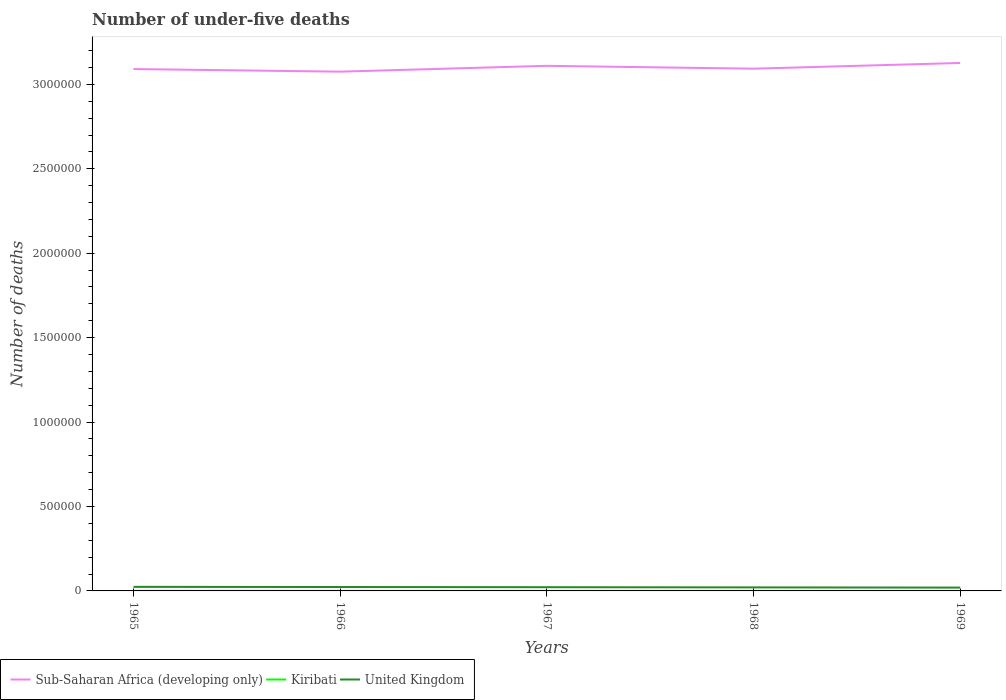Across all years, what is the maximum number of under-five deaths in Kiribati?
Provide a short and direct response. 256. In which year was the number of under-five deaths in United Kingdom maximum?
Offer a terse response. 1969. What is the total number of under-five deaths in Sub-Saharan Africa (developing only) in the graph?
Give a very brief answer. 1.54e+04. What is the difference between the highest and the second highest number of under-five deaths in Sub-Saharan Africa (developing only)?
Your response must be concise. 5.14e+04. How many years are there in the graph?
Your answer should be very brief. 5. Are the values on the major ticks of Y-axis written in scientific E-notation?
Your response must be concise. No. How many legend labels are there?
Make the answer very short. 3. How are the legend labels stacked?
Your answer should be very brief. Horizontal. What is the title of the graph?
Offer a terse response. Number of under-five deaths. Does "Argentina" appear as one of the legend labels in the graph?
Your response must be concise. No. What is the label or title of the X-axis?
Provide a short and direct response. Years. What is the label or title of the Y-axis?
Provide a succinct answer. Number of deaths. What is the Number of deaths of Sub-Saharan Africa (developing only) in 1965?
Make the answer very short. 3.09e+06. What is the Number of deaths of Kiribati in 1965?
Keep it short and to the point. 321. What is the Number of deaths in United Kingdom in 1965?
Your answer should be very brief. 2.41e+04. What is the Number of deaths of Sub-Saharan Africa (developing only) in 1966?
Your answer should be very brief. 3.08e+06. What is the Number of deaths of Kiribati in 1966?
Give a very brief answer. 306. What is the Number of deaths in United Kingdom in 1966?
Give a very brief answer. 2.32e+04. What is the Number of deaths in Sub-Saharan Africa (developing only) in 1967?
Ensure brevity in your answer.  3.11e+06. What is the Number of deaths of Kiribati in 1967?
Your answer should be compact. 289. What is the Number of deaths of United Kingdom in 1967?
Ensure brevity in your answer.  2.20e+04. What is the Number of deaths of Sub-Saharan Africa (developing only) in 1968?
Your answer should be very brief. 3.09e+06. What is the Number of deaths of Kiribati in 1968?
Your answer should be very brief. 272. What is the Number of deaths in United Kingdom in 1968?
Your answer should be very brief. 2.09e+04. What is the Number of deaths of Sub-Saharan Africa (developing only) in 1969?
Keep it short and to the point. 3.13e+06. What is the Number of deaths in Kiribati in 1969?
Provide a short and direct response. 256. What is the Number of deaths of United Kingdom in 1969?
Provide a short and direct response. 1.97e+04. Across all years, what is the maximum Number of deaths of Sub-Saharan Africa (developing only)?
Offer a terse response. 3.13e+06. Across all years, what is the maximum Number of deaths in Kiribati?
Ensure brevity in your answer.  321. Across all years, what is the maximum Number of deaths of United Kingdom?
Give a very brief answer. 2.41e+04. Across all years, what is the minimum Number of deaths of Sub-Saharan Africa (developing only)?
Provide a succinct answer. 3.08e+06. Across all years, what is the minimum Number of deaths in Kiribati?
Ensure brevity in your answer.  256. Across all years, what is the minimum Number of deaths in United Kingdom?
Your response must be concise. 1.97e+04. What is the total Number of deaths of Sub-Saharan Africa (developing only) in the graph?
Make the answer very short. 1.55e+07. What is the total Number of deaths of Kiribati in the graph?
Provide a short and direct response. 1444. What is the total Number of deaths in United Kingdom in the graph?
Give a very brief answer. 1.10e+05. What is the difference between the Number of deaths in Sub-Saharan Africa (developing only) in 1965 and that in 1966?
Make the answer very short. 1.54e+04. What is the difference between the Number of deaths in United Kingdom in 1965 and that in 1966?
Provide a short and direct response. 955. What is the difference between the Number of deaths of Sub-Saharan Africa (developing only) in 1965 and that in 1967?
Offer a very short reply. -1.91e+04. What is the difference between the Number of deaths of Kiribati in 1965 and that in 1967?
Keep it short and to the point. 32. What is the difference between the Number of deaths in United Kingdom in 1965 and that in 1967?
Ensure brevity in your answer.  2127. What is the difference between the Number of deaths of Sub-Saharan Africa (developing only) in 1965 and that in 1968?
Provide a short and direct response. -2131. What is the difference between the Number of deaths in United Kingdom in 1965 and that in 1968?
Provide a short and direct response. 3232. What is the difference between the Number of deaths in Sub-Saharan Africa (developing only) in 1965 and that in 1969?
Make the answer very short. -3.60e+04. What is the difference between the Number of deaths in Kiribati in 1965 and that in 1969?
Your answer should be very brief. 65. What is the difference between the Number of deaths of United Kingdom in 1965 and that in 1969?
Your answer should be compact. 4390. What is the difference between the Number of deaths of Sub-Saharan Africa (developing only) in 1966 and that in 1967?
Provide a short and direct response. -3.45e+04. What is the difference between the Number of deaths in United Kingdom in 1966 and that in 1967?
Your answer should be very brief. 1172. What is the difference between the Number of deaths in Sub-Saharan Africa (developing only) in 1966 and that in 1968?
Your answer should be very brief. -1.76e+04. What is the difference between the Number of deaths in Kiribati in 1966 and that in 1968?
Ensure brevity in your answer.  34. What is the difference between the Number of deaths of United Kingdom in 1966 and that in 1968?
Offer a very short reply. 2277. What is the difference between the Number of deaths of Sub-Saharan Africa (developing only) in 1966 and that in 1969?
Your answer should be compact. -5.14e+04. What is the difference between the Number of deaths in Kiribati in 1966 and that in 1969?
Offer a terse response. 50. What is the difference between the Number of deaths of United Kingdom in 1966 and that in 1969?
Your response must be concise. 3435. What is the difference between the Number of deaths in Sub-Saharan Africa (developing only) in 1967 and that in 1968?
Offer a terse response. 1.70e+04. What is the difference between the Number of deaths in United Kingdom in 1967 and that in 1968?
Keep it short and to the point. 1105. What is the difference between the Number of deaths of Sub-Saharan Africa (developing only) in 1967 and that in 1969?
Make the answer very short. -1.69e+04. What is the difference between the Number of deaths in United Kingdom in 1967 and that in 1969?
Provide a short and direct response. 2263. What is the difference between the Number of deaths in Sub-Saharan Africa (developing only) in 1968 and that in 1969?
Your response must be concise. -3.39e+04. What is the difference between the Number of deaths of Kiribati in 1968 and that in 1969?
Provide a succinct answer. 16. What is the difference between the Number of deaths in United Kingdom in 1968 and that in 1969?
Keep it short and to the point. 1158. What is the difference between the Number of deaths in Sub-Saharan Africa (developing only) in 1965 and the Number of deaths in Kiribati in 1966?
Your response must be concise. 3.09e+06. What is the difference between the Number of deaths of Sub-Saharan Africa (developing only) in 1965 and the Number of deaths of United Kingdom in 1966?
Keep it short and to the point. 3.07e+06. What is the difference between the Number of deaths in Kiribati in 1965 and the Number of deaths in United Kingdom in 1966?
Provide a succinct answer. -2.28e+04. What is the difference between the Number of deaths in Sub-Saharan Africa (developing only) in 1965 and the Number of deaths in Kiribati in 1967?
Provide a succinct answer. 3.09e+06. What is the difference between the Number of deaths in Sub-Saharan Africa (developing only) in 1965 and the Number of deaths in United Kingdom in 1967?
Provide a short and direct response. 3.07e+06. What is the difference between the Number of deaths in Kiribati in 1965 and the Number of deaths in United Kingdom in 1967?
Keep it short and to the point. -2.17e+04. What is the difference between the Number of deaths of Sub-Saharan Africa (developing only) in 1965 and the Number of deaths of Kiribati in 1968?
Your answer should be very brief. 3.09e+06. What is the difference between the Number of deaths in Sub-Saharan Africa (developing only) in 1965 and the Number of deaths in United Kingdom in 1968?
Provide a succinct answer. 3.07e+06. What is the difference between the Number of deaths in Kiribati in 1965 and the Number of deaths in United Kingdom in 1968?
Provide a succinct answer. -2.06e+04. What is the difference between the Number of deaths in Sub-Saharan Africa (developing only) in 1965 and the Number of deaths in Kiribati in 1969?
Keep it short and to the point. 3.09e+06. What is the difference between the Number of deaths of Sub-Saharan Africa (developing only) in 1965 and the Number of deaths of United Kingdom in 1969?
Offer a terse response. 3.07e+06. What is the difference between the Number of deaths in Kiribati in 1965 and the Number of deaths in United Kingdom in 1969?
Give a very brief answer. -1.94e+04. What is the difference between the Number of deaths in Sub-Saharan Africa (developing only) in 1966 and the Number of deaths in Kiribati in 1967?
Make the answer very short. 3.07e+06. What is the difference between the Number of deaths in Sub-Saharan Africa (developing only) in 1966 and the Number of deaths in United Kingdom in 1967?
Give a very brief answer. 3.05e+06. What is the difference between the Number of deaths in Kiribati in 1966 and the Number of deaths in United Kingdom in 1967?
Your answer should be compact. -2.17e+04. What is the difference between the Number of deaths of Sub-Saharan Africa (developing only) in 1966 and the Number of deaths of Kiribati in 1968?
Ensure brevity in your answer.  3.07e+06. What is the difference between the Number of deaths in Sub-Saharan Africa (developing only) in 1966 and the Number of deaths in United Kingdom in 1968?
Make the answer very short. 3.05e+06. What is the difference between the Number of deaths in Kiribati in 1966 and the Number of deaths in United Kingdom in 1968?
Keep it short and to the point. -2.06e+04. What is the difference between the Number of deaths of Sub-Saharan Africa (developing only) in 1966 and the Number of deaths of Kiribati in 1969?
Your answer should be compact. 3.07e+06. What is the difference between the Number of deaths of Sub-Saharan Africa (developing only) in 1966 and the Number of deaths of United Kingdom in 1969?
Offer a terse response. 3.06e+06. What is the difference between the Number of deaths of Kiribati in 1966 and the Number of deaths of United Kingdom in 1969?
Give a very brief answer. -1.94e+04. What is the difference between the Number of deaths in Sub-Saharan Africa (developing only) in 1967 and the Number of deaths in Kiribati in 1968?
Provide a short and direct response. 3.11e+06. What is the difference between the Number of deaths of Sub-Saharan Africa (developing only) in 1967 and the Number of deaths of United Kingdom in 1968?
Ensure brevity in your answer.  3.09e+06. What is the difference between the Number of deaths in Kiribati in 1967 and the Number of deaths in United Kingdom in 1968?
Your response must be concise. -2.06e+04. What is the difference between the Number of deaths of Sub-Saharan Africa (developing only) in 1967 and the Number of deaths of Kiribati in 1969?
Offer a very short reply. 3.11e+06. What is the difference between the Number of deaths of Sub-Saharan Africa (developing only) in 1967 and the Number of deaths of United Kingdom in 1969?
Offer a very short reply. 3.09e+06. What is the difference between the Number of deaths of Kiribati in 1967 and the Number of deaths of United Kingdom in 1969?
Keep it short and to the point. -1.94e+04. What is the difference between the Number of deaths of Sub-Saharan Africa (developing only) in 1968 and the Number of deaths of Kiribati in 1969?
Your answer should be compact. 3.09e+06. What is the difference between the Number of deaths in Sub-Saharan Africa (developing only) in 1968 and the Number of deaths in United Kingdom in 1969?
Provide a succinct answer. 3.07e+06. What is the difference between the Number of deaths in Kiribati in 1968 and the Number of deaths in United Kingdom in 1969?
Your answer should be very brief. -1.94e+04. What is the average Number of deaths in Sub-Saharan Africa (developing only) per year?
Offer a very short reply. 3.10e+06. What is the average Number of deaths of Kiribati per year?
Your answer should be compact. 288.8. What is the average Number of deaths of United Kingdom per year?
Your response must be concise. 2.20e+04. In the year 1965, what is the difference between the Number of deaths of Sub-Saharan Africa (developing only) and Number of deaths of Kiribati?
Offer a very short reply. 3.09e+06. In the year 1965, what is the difference between the Number of deaths in Sub-Saharan Africa (developing only) and Number of deaths in United Kingdom?
Your answer should be compact. 3.07e+06. In the year 1965, what is the difference between the Number of deaths in Kiribati and Number of deaths in United Kingdom?
Keep it short and to the point. -2.38e+04. In the year 1966, what is the difference between the Number of deaths of Sub-Saharan Africa (developing only) and Number of deaths of Kiribati?
Your answer should be very brief. 3.07e+06. In the year 1966, what is the difference between the Number of deaths of Sub-Saharan Africa (developing only) and Number of deaths of United Kingdom?
Keep it short and to the point. 3.05e+06. In the year 1966, what is the difference between the Number of deaths of Kiribati and Number of deaths of United Kingdom?
Your answer should be compact. -2.28e+04. In the year 1967, what is the difference between the Number of deaths in Sub-Saharan Africa (developing only) and Number of deaths in Kiribati?
Your response must be concise. 3.11e+06. In the year 1967, what is the difference between the Number of deaths of Sub-Saharan Africa (developing only) and Number of deaths of United Kingdom?
Your answer should be very brief. 3.09e+06. In the year 1967, what is the difference between the Number of deaths of Kiribati and Number of deaths of United Kingdom?
Give a very brief answer. -2.17e+04. In the year 1968, what is the difference between the Number of deaths in Sub-Saharan Africa (developing only) and Number of deaths in Kiribati?
Your response must be concise. 3.09e+06. In the year 1968, what is the difference between the Number of deaths of Sub-Saharan Africa (developing only) and Number of deaths of United Kingdom?
Make the answer very short. 3.07e+06. In the year 1968, what is the difference between the Number of deaths of Kiribati and Number of deaths of United Kingdom?
Ensure brevity in your answer.  -2.06e+04. In the year 1969, what is the difference between the Number of deaths of Sub-Saharan Africa (developing only) and Number of deaths of Kiribati?
Give a very brief answer. 3.13e+06. In the year 1969, what is the difference between the Number of deaths of Sub-Saharan Africa (developing only) and Number of deaths of United Kingdom?
Your answer should be very brief. 3.11e+06. In the year 1969, what is the difference between the Number of deaths of Kiribati and Number of deaths of United Kingdom?
Provide a succinct answer. -1.95e+04. What is the ratio of the Number of deaths in Kiribati in 1965 to that in 1966?
Your response must be concise. 1.05. What is the ratio of the Number of deaths of United Kingdom in 1965 to that in 1966?
Your response must be concise. 1.04. What is the ratio of the Number of deaths in Sub-Saharan Africa (developing only) in 1965 to that in 1967?
Offer a very short reply. 0.99. What is the ratio of the Number of deaths in Kiribati in 1965 to that in 1967?
Offer a very short reply. 1.11. What is the ratio of the Number of deaths in United Kingdom in 1965 to that in 1967?
Provide a short and direct response. 1.1. What is the ratio of the Number of deaths of Kiribati in 1965 to that in 1968?
Offer a very short reply. 1.18. What is the ratio of the Number of deaths of United Kingdom in 1965 to that in 1968?
Keep it short and to the point. 1.15. What is the ratio of the Number of deaths of Sub-Saharan Africa (developing only) in 1965 to that in 1969?
Offer a terse response. 0.99. What is the ratio of the Number of deaths of Kiribati in 1965 to that in 1969?
Provide a succinct answer. 1.25. What is the ratio of the Number of deaths of United Kingdom in 1965 to that in 1969?
Provide a short and direct response. 1.22. What is the ratio of the Number of deaths of Sub-Saharan Africa (developing only) in 1966 to that in 1967?
Provide a short and direct response. 0.99. What is the ratio of the Number of deaths in Kiribati in 1966 to that in 1967?
Make the answer very short. 1.06. What is the ratio of the Number of deaths in United Kingdom in 1966 to that in 1967?
Give a very brief answer. 1.05. What is the ratio of the Number of deaths in Sub-Saharan Africa (developing only) in 1966 to that in 1968?
Provide a succinct answer. 0.99. What is the ratio of the Number of deaths of Kiribati in 1966 to that in 1968?
Keep it short and to the point. 1.12. What is the ratio of the Number of deaths in United Kingdom in 1966 to that in 1968?
Keep it short and to the point. 1.11. What is the ratio of the Number of deaths of Sub-Saharan Africa (developing only) in 1966 to that in 1969?
Offer a terse response. 0.98. What is the ratio of the Number of deaths in Kiribati in 1966 to that in 1969?
Provide a succinct answer. 1.2. What is the ratio of the Number of deaths of United Kingdom in 1966 to that in 1969?
Offer a very short reply. 1.17. What is the ratio of the Number of deaths of Sub-Saharan Africa (developing only) in 1967 to that in 1968?
Keep it short and to the point. 1.01. What is the ratio of the Number of deaths of Kiribati in 1967 to that in 1968?
Make the answer very short. 1.06. What is the ratio of the Number of deaths in United Kingdom in 1967 to that in 1968?
Give a very brief answer. 1.05. What is the ratio of the Number of deaths of Kiribati in 1967 to that in 1969?
Make the answer very short. 1.13. What is the ratio of the Number of deaths in United Kingdom in 1967 to that in 1969?
Offer a terse response. 1.11. What is the ratio of the Number of deaths in Sub-Saharan Africa (developing only) in 1968 to that in 1969?
Make the answer very short. 0.99. What is the ratio of the Number of deaths in United Kingdom in 1968 to that in 1969?
Keep it short and to the point. 1.06. What is the difference between the highest and the second highest Number of deaths in Sub-Saharan Africa (developing only)?
Offer a very short reply. 1.69e+04. What is the difference between the highest and the second highest Number of deaths of Kiribati?
Provide a succinct answer. 15. What is the difference between the highest and the second highest Number of deaths in United Kingdom?
Provide a succinct answer. 955. What is the difference between the highest and the lowest Number of deaths in Sub-Saharan Africa (developing only)?
Ensure brevity in your answer.  5.14e+04. What is the difference between the highest and the lowest Number of deaths in United Kingdom?
Your response must be concise. 4390. 